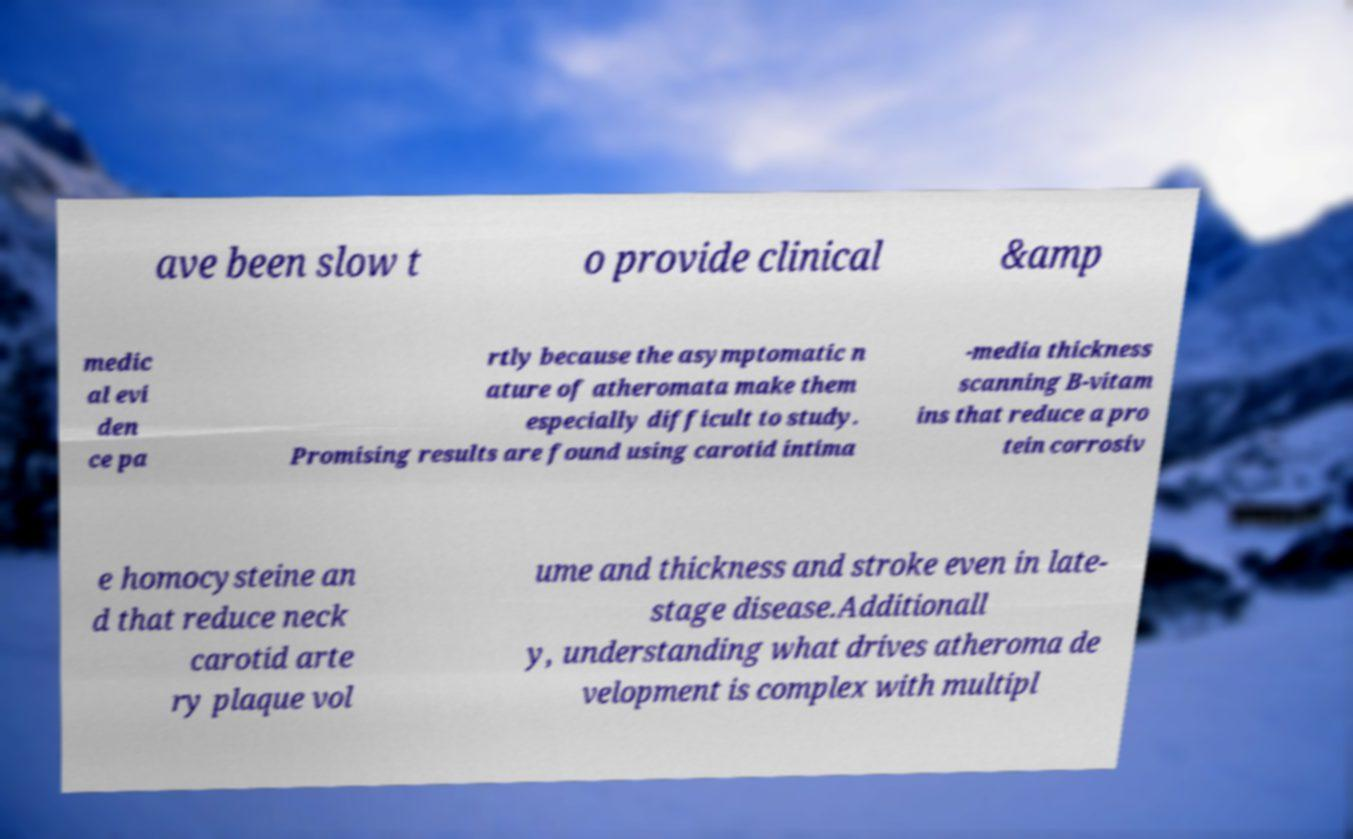For documentation purposes, I need the text within this image transcribed. Could you provide that? ave been slow t o provide clinical &amp medic al evi den ce pa rtly because the asymptomatic n ature of atheromata make them especially difficult to study. Promising results are found using carotid intima -media thickness scanning B-vitam ins that reduce a pro tein corrosiv e homocysteine an d that reduce neck carotid arte ry plaque vol ume and thickness and stroke even in late- stage disease.Additionall y, understanding what drives atheroma de velopment is complex with multipl 